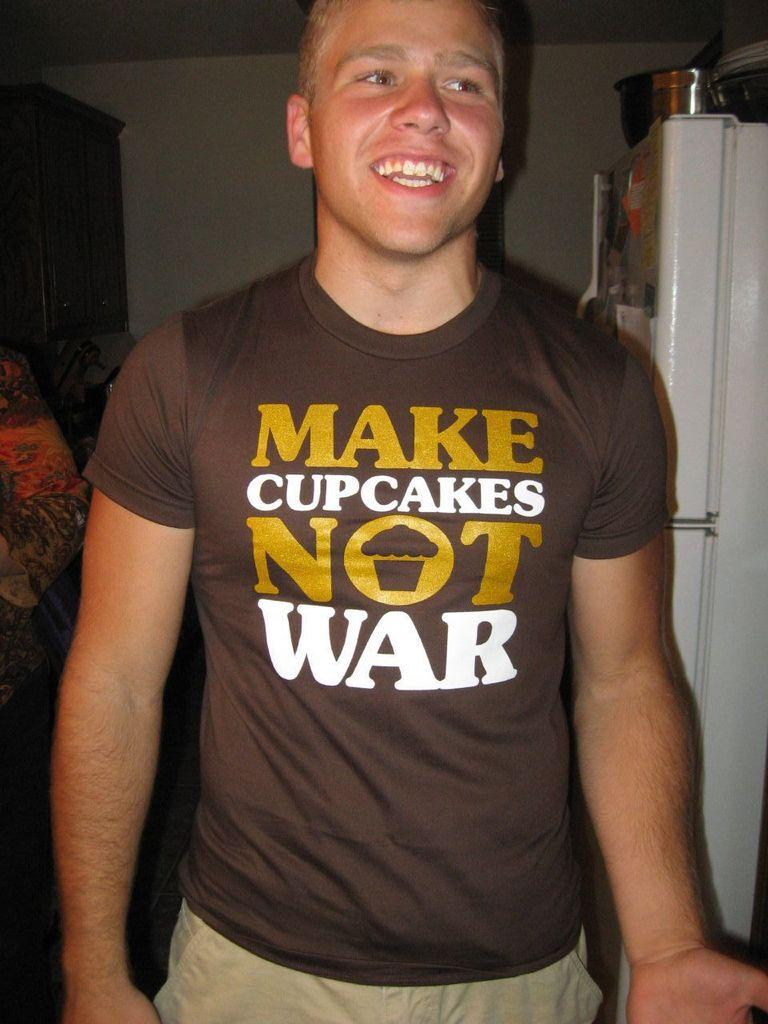<image>
Provide a brief description of the given image. A man is wearing a brown shirt that says Make Cupcakes Not War. 